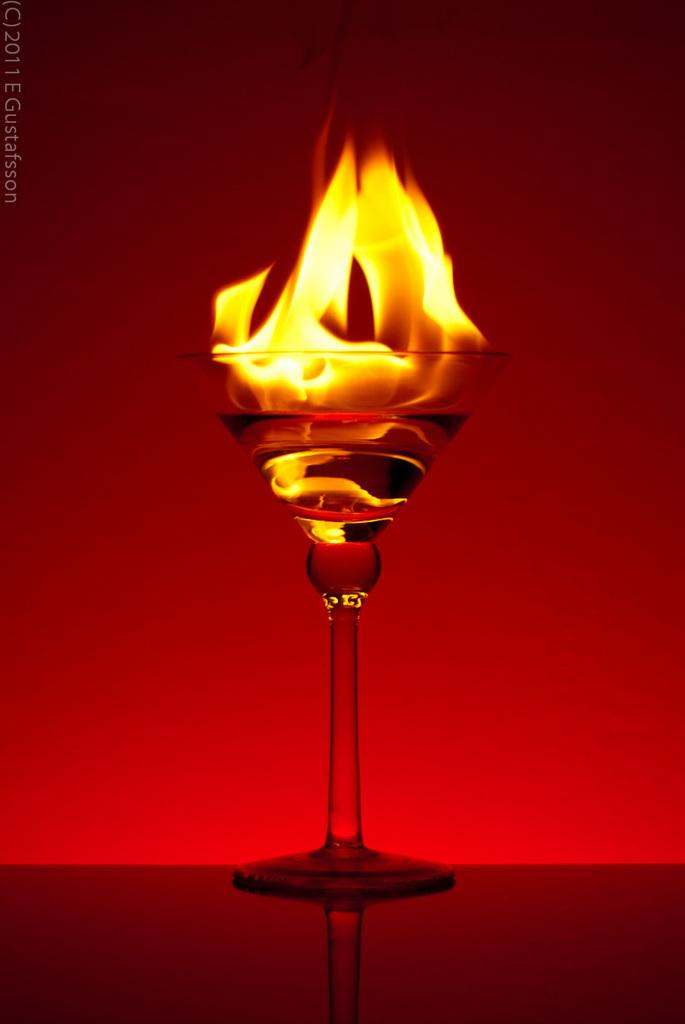What is happening inside the glass in the image? There is a fire in a glass in the image. Where is the glass placed in the image? The glass is placed on a surface in the image. Can you describe any additional features of the image? There is a watermark in the top left corner of the image, and the background color is red. How does the fire in the glass taste in the image? The fire in the glass cannot be tasted, as it is a visual representation in the image. 